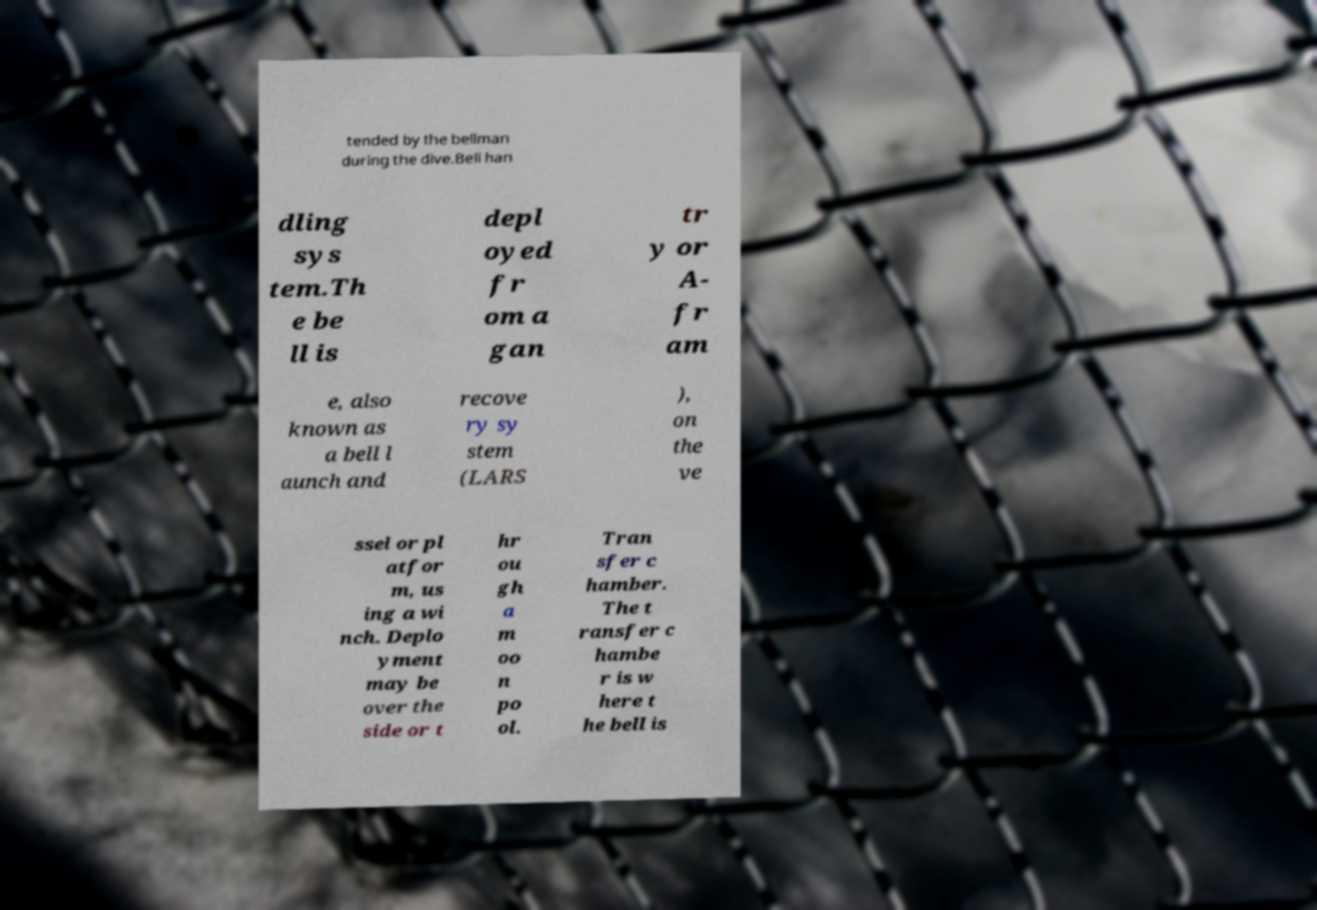Can you read and provide the text displayed in the image?This photo seems to have some interesting text. Can you extract and type it out for me? tended by the bellman during the dive.Bell han dling sys tem.Th e be ll is depl oyed fr om a gan tr y or A- fr am e, also known as a bell l aunch and recove ry sy stem (LARS ), on the ve ssel or pl atfor m, us ing a wi nch. Deplo yment may be over the side or t hr ou gh a m oo n po ol. Tran sfer c hamber. The t ransfer c hambe r is w here t he bell is 